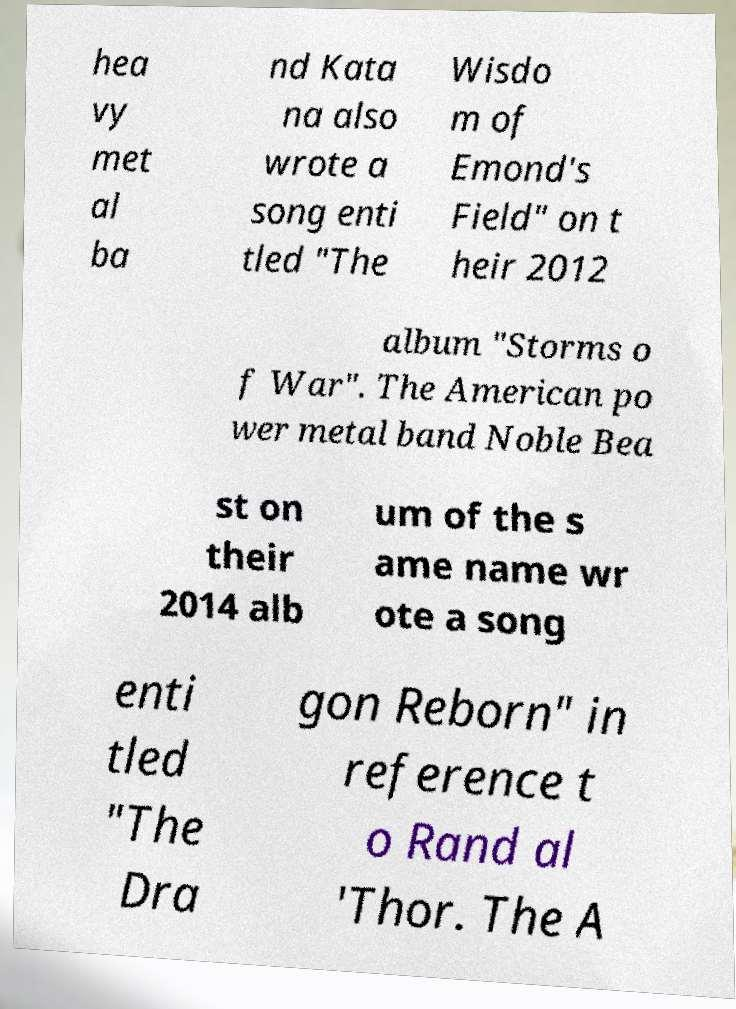I need the written content from this picture converted into text. Can you do that? hea vy met al ba nd Kata na also wrote a song enti tled "The Wisdo m of Emond's Field" on t heir 2012 album "Storms o f War". The American po wer metal band Noble Bea st on their 2014 alb um of the s ame name wr ote a song enti tled "The Dra gon Reborn" in reference t o Rand al 'Thor. The A 